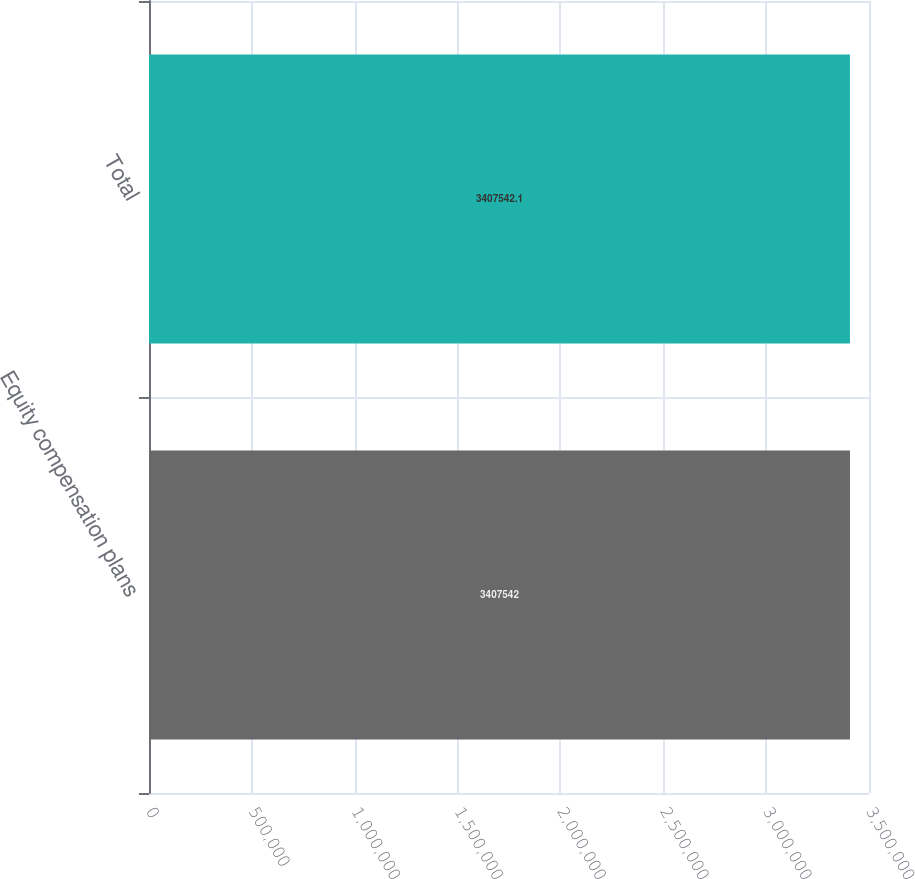Convert chart to OTSL. <chart><loc_0><loc_0><loc_500><loc_500><bar_chart><fcel>Equity compensation plans<fcel>Total<nl><fcel>3.40754e+06<fcel>3.40754e+06<nl></chart> 